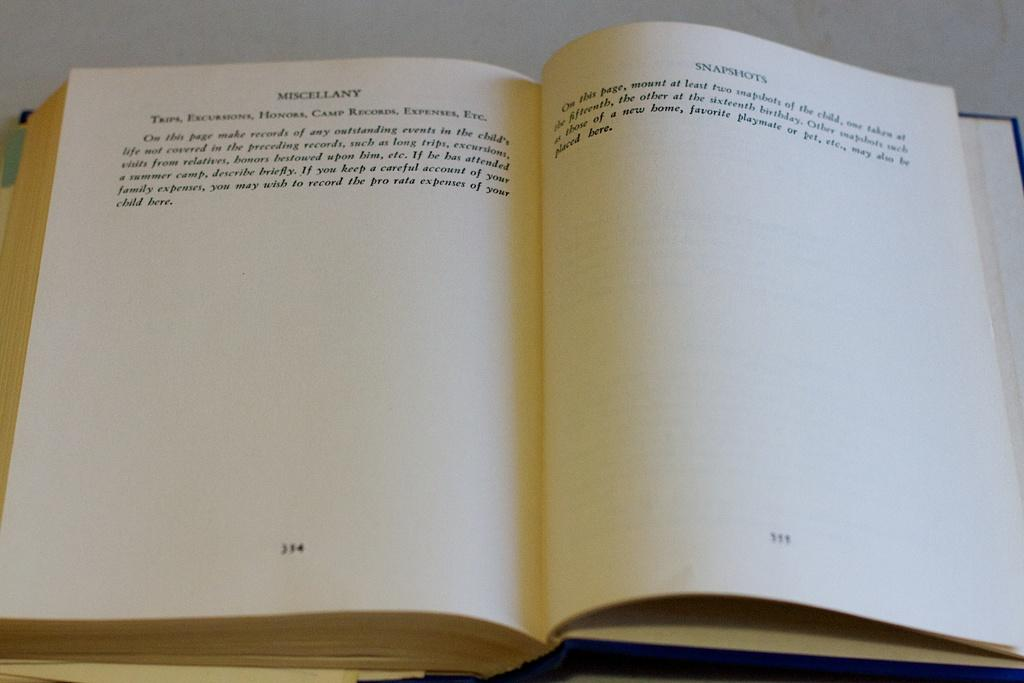What is the main object in the foreground of the image? There is a book in the foreground of the image. What can be found on the book? There is text on the book. Can you hear the thunder in the image? There is no mention of thunder in the image, so it cannot be heard. 